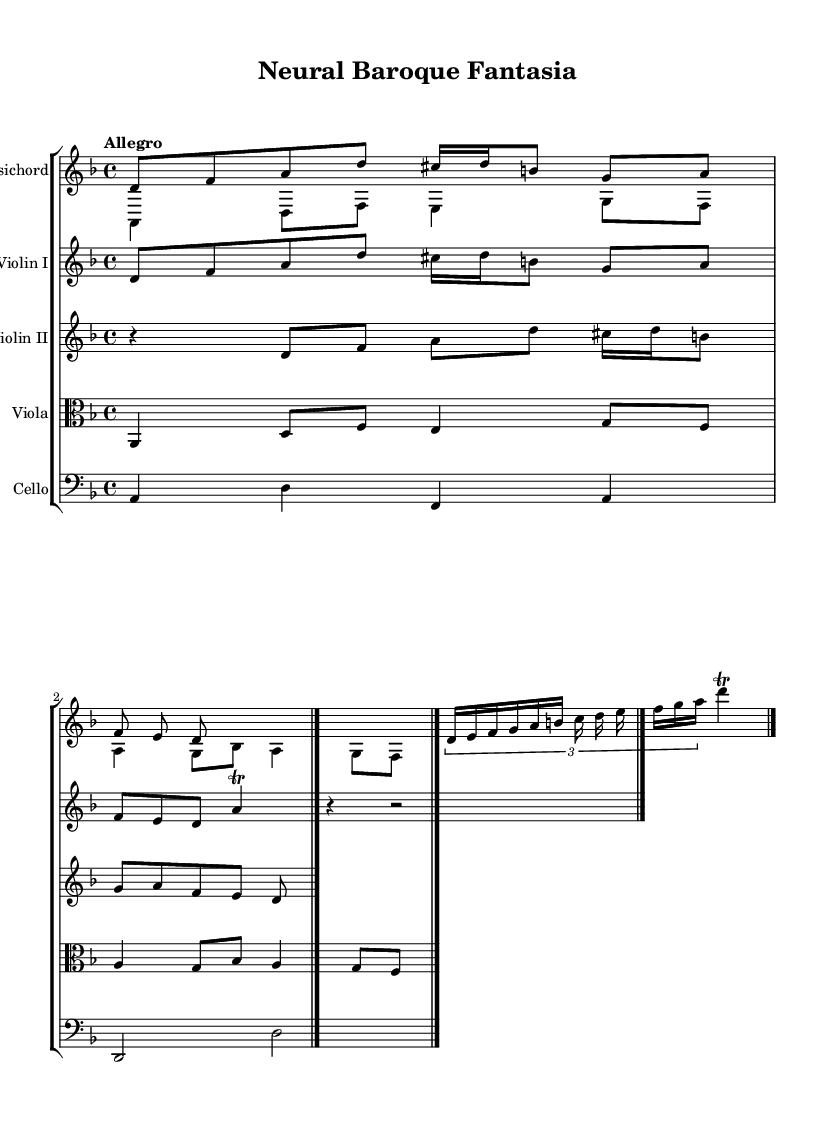What is the key signature of this music? The key signature is indicated by the sharp or flat symbols at the beginning of the staff. In this case, there are no sharps or flats, indicating the key of D minor.
Answer: D minor What is the time signature of this music? The time signature is shown as a fraction at the beginning of the first staff. Here, it is 4/4, meaning there are four beats in each measure and the quarter note gets one beat.
Answer: 4/4 What is the tempo marking of this music? The tempo marking is located at the beginning, typically right after the time signature. In this case, it states "Allegro," indicating a fast and lively pace.
Answer: Allegro How many voices are present in the harpsichord part? The harpsichord part is divided into two voices, as indicated by the separate lines labeled Voice One and Voice Two.
Answer: Two What type of musical form does this piece represent? Analyzing the structure, there are repeated themes and interwoven melodies, which suggests a form common in Baroque music known as a fantasia, where themes are developed freely.
Answer: Fantasia In which manner does the violin I part conclude? The conclusion of the violin I part shows the presence of a rest followed by a double bar line, signaling the end of a section.
Answer: Double bar line How does the counter theme interact with the main theme? The counter theme is played concurrently with the main theme, creating a complex interplay of melodies characteristic of Baroque compositions. This is evident as both themes are featured together.
Answer: Interwoven melodies 